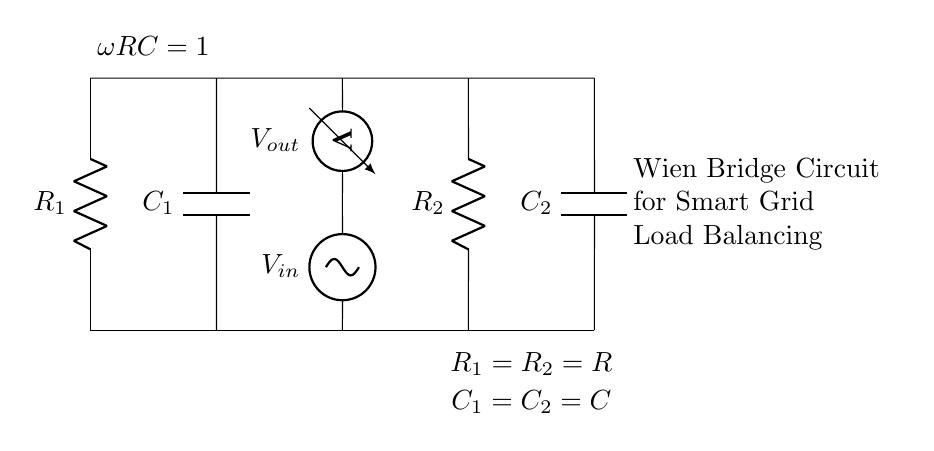What are the components in the circuit? The circuit contains two resistors, two capacitors, a sinusoidal voltage source, and a voltmeter. The labels on the circuit specify the components: R1, R2 for resistors and C1, C2 for capacitors.
Answer: Resistors, capacitors, voltage source, voltmeter What is the relationship between R1 and R2? The circuit indicates that R1 and R2 are equal, as stated in the annotations near the resistors. This is denoted by R1 = R2 = R.
Answer: R1 = R2 What does the voltage source represent in the circuit? The sinusoidal voltage source signifies the input voltage (Vin), which provides alternating current to the circuit for analysis.
Answer: Vin What is the significance of the label "omega RC = 1"? This label represents the condition for the Wien bridge to achieve resonance, where omega is the angular frequency, and RC is the time constant of the circuit. This relationship is crucial for frequency analysis in a Wien bridge circuit.
Answer: Resonance condition Which components are responsible for frequency analysis in this circuit? The capacitors (C1 and C2) and the resistors (R1 and R2) together define the frequency response of the Wien bridge circuit. Their values determine the frequencies at which the circuit can operate effectively for load balancing.
Answer: Resistors and capacitors What characteristic of the circuit indicates it is a Wien bridge? The presence of the specific configuration of two resistors and two capacitors in a bridge arrangement is characteristic of a Wien bridge. This structure is typically used in applications for precise frequency measurements.
Answer: Bridge configuration 